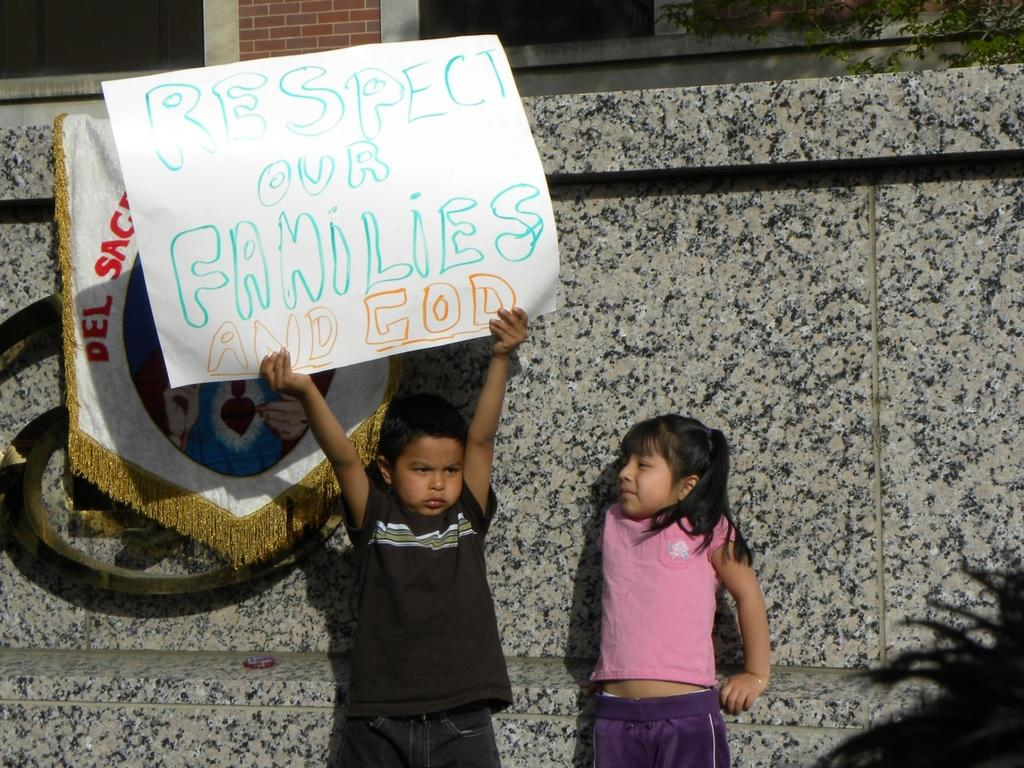How many children are in the image? There are two children in the image: a boy and a girl. What are the positions of the children in the image? Both the boy and the girl are standing. What is the boy holding in the image? The boy is holding a paper. What type of decoration or signage is present in the image? There is a kind of banner present in the image. What can be seen in the background of the image? There is a wall in the background of the image. What type of railway is visible in the image? There is no railway present in the image. What liquid is being consumed by the children in the image? There is no liquid consumption depicted in the image. 